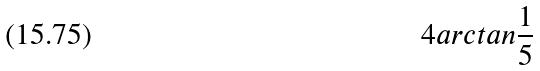<formula> <loc_0><loc_0><loc_500><loc_500>4 a r c t a n \frac { 1 } { 5 }</formula> 